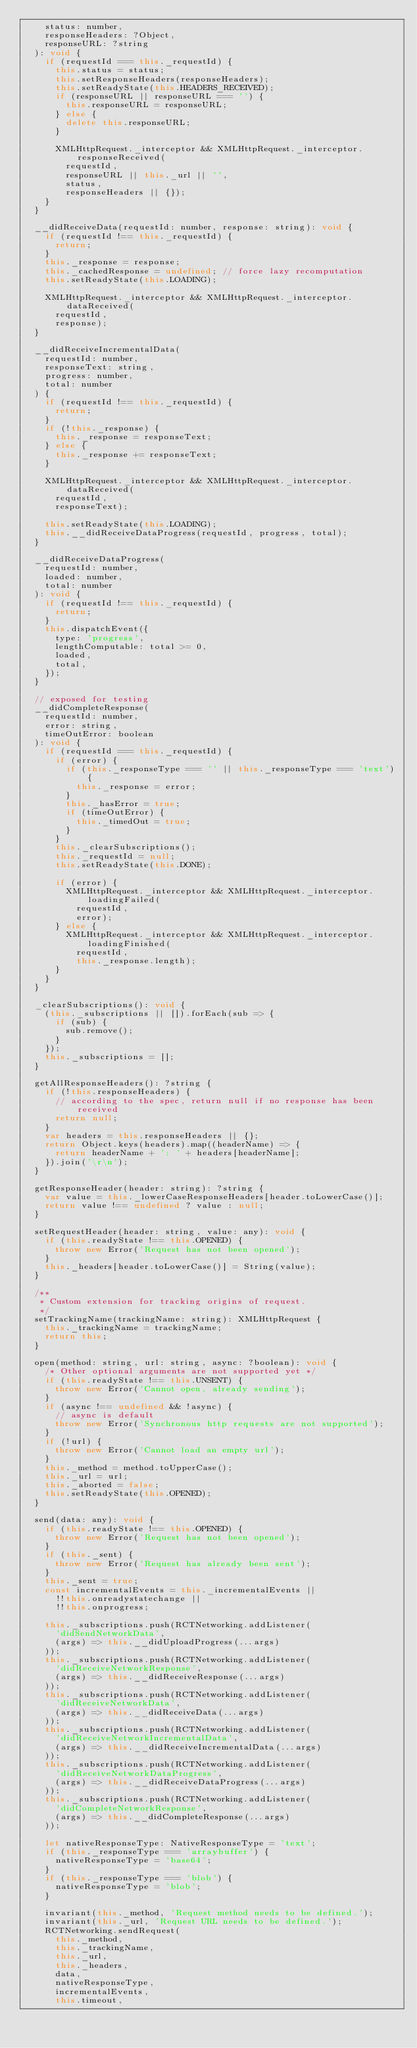Convert code to text. <code><loc_0><loc_0><loc_500><loc_500><_JavaScript_>    status: number,
    responseHeaders: ?Object,
    responseURL: ?string
  ): void {
    if (requestId === this._requestId) {
      this.status = status;
      this.setResponseHeaders(responseHeaders);
      this.setReadyState(this.HEADERS_RECEIVED);
      if (responseURL || responseURL === '') {
        this.responseURL = responseURL;
      } else {
        delete this.responseURL;
      }

      XMLHttpRequest._interceptor && XMLHttpRequest._interceptor.responseReceived(
        requestId,
        responseURL || this._url || '',
        status,
        responseHeaders || {});
    }
  }

  __didReceiveData(requestId: number, response: string): void {
    if (requestId !== this._requestId) {
      return;
    }
    this._response = response;
    this._cachedResponse = undefined; // force lazy recomputation
    this.setReadyState(this.LOADING);

    XMLHttpRequest._interceptor && XMLHttpRequest._interceptor.dataReceived(
      requestId,
      response);
  }

  __didReceiveIncrementalData(
    requestId: number,
    responseText: string,
    progress: number,
    total: number
  ) {
    if (requestId !== this._requestId) {
      return;
    }
    if (!this._response) {
      this._response = responseText;
    } else {
      this._response += responseText;
    }

    XMLHttpRequest._interceptor && XMLHttpRequest._interceptor.dataReceived(
      requestId,
      responseText);

    this.setReadyState(this.LOADING);
    this.__didReceiveDataProgress(requestId, progress, total);
  }

  __didReceiveDataProgress(
    requestId: number,
    loaded: number,
    total: number
  ): void {
    if (requestId !== this._requestId) {
      return;
    }
    this.dispatchEvent({
      type: 'progress',
      lengthComputable: total >= 0,
      loaded,
      total,
    });
  }

  // exposed for testing
  __didCompleteResponse(
    requestId: number,
    error: string,
    timeOutError: boolean
  ): void {
    if (requestId === this._requestId) {
      if (error) {
        if (this._responseType === '' || this._responseType === 'text') {
          this._response = error;
        }
        this._hasError = true;
        if (timeOutError) {
          this._timedOut = true;
        }
      }
      this._clearSubscriptions();
      this._requestId = null;
      this.setReadyState(this.DONE);

      if (error) {
        XMLHttpRequest._interceptor && XMLHttpRequest._interceptor.loadingFailed(
          requestId,
          error);
      } else {
        XMLHttpRequest._interceptor && XMLHttpRequest._interceptor.loadingFinished(
          requestId,
          this._response.length);
      }
    }
  }

  _clearSubscriptions(): void {
    (this._subscriptions || []).forEach(sub => {
      if (sub) {
        sub.remove();
      }
    });
    this._subscriptions = [];
  }

  getAllResponseHeaders(): ?string {
    if (!this.responseHeaders) {
      // according to the spec, return null if no response has been received
      return null;
    }
    var headers = this.responseHeaders || {};
    return Object.keys(headers).map((headerName) => {
      return headerName + ': ' + headers[headerName];
    }).join('\r\n');
  }

  getResponseHeader(header: string): ?string {
    var value = this._lowerCaseResponseHeaders[header.toLowerCase()];
    return value !== undefined ? value : null;
  }

  setRequestHeader(header: string, value: any): void {
    if (this.readyState !== this.OPENED) {
      throw new Error('Request has not been opened');
    }
    this._headers[header.toLowerCase()] = String(value);
  }

  /**
   * Custom extension for tracking origins of request.
   */
  setTrackingName(trackingName: string): XMLHttpRequest {
    this._trackingName = trackingName;
    return this;
  }

  open(method: string, url: string, async: ?boolean): void {
    /* Other optional arguments are not supported yet */
    if (this.readyState !== this.UNSENT) {
      throw new Error('Cannot open, already sending');
    }
    if (async !== undefined && !async) {
      // async is default
      throw new Error('Synchronous http requests are not supported');
    }
    if (!url) {
      throw new Error('Cannot load an empty url');
    }
    this._method = method.toUpperCase();
    this._url = url;
    this._aborted = false;
    this.setReadyState(this.OPENED);
  }

  send(data: any): void {
    if (this.readyState !== this.OPENED) {
      throw new Error('Request has not been opened');
    }
    if (this._sent) {
      throw new Error('Request has already been sent');
    }
    this._sent = true;
    const incrementalEvents = this._incrementalEvents ||
      !!this.onreadystatechange ||
      !!this.onprogress;

    this._subscriptions.push(RCTNetworking.addListener(
      'didSendNetworkData',
      (args) => this.__didUploadProgress(...args)
    ));
    this._subscriptions.push(RCTNetworking.addListener(
      'didReceiveNetworkResponse',
      (args) => this.__didReceiveResponse(...args)
    ));
    this._subscriptions.push(RCTNetworking.addListener(
      'didReceiveNetworkData',
      (args) => this.__didReceiveData(...args)
    ));
    this._subscriptions.push(RCTNetworking.addListener(
      'didReceiveNetworkIncrementalData',
      (args) => this.__didReceiveIncrementalData(...args)
    ));
    this._subscriptions.push(RCTNetworking.addListener(
      'didReceiveNetworkDataProgress',
      (args) => this.__didReceiveDataProgress(...args)
    ));
    this._subscriptions.push(RCTNetworking.addListener(
      'didCompleteNetworkResponse',
      (args) => this.__didCompleteResponse(...args)
    ));

    let nativeResponseType: NativeResponseType = 'text';
    if (this._responseType === 'arraybuffer') {
      nativeResponseType = 'base64';
    }
    if (this._responseType === 'blob') {
      nativeResponseType = 'blob';
    }

    invariant(this._method, 'Request method needs to be defined.');
    invariant(this._url, 'Request URL needs to be defined.');
    RCTNetworking.sendRequest(
      this._method,
      this._trackingName,
      this._url,
      this._headers,
      data,
      nativeResponseType,
      incrementalEvents,
      this.timeout,</code> 